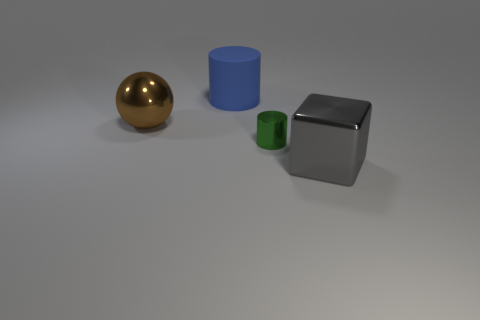Add 4 blue cylinders. How many objects exist? 8 Subtract all brown blocks. Subtract all gray spheres. How many blocks are left? 1 Subtract all cubes. How many objects are left? 3 Subtract all cyan matte objects. Subtract all large matte things. How many objects are left? 3 Add 3 large metallic objects. How many large metallic objects are left? 5 Add 4 green cubes. How many green cubes exist? 4 Subtract 0 yellow balls. How many objects are left? 4 